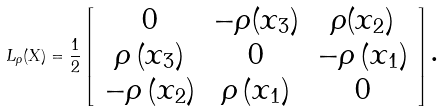Convert formula to latex. <formula><loc_0><loc_0><loc_500><loc_500>L _ { \rho } ( X ) = \frac { 1 } { 2 } \left [ \begin{array} { c c c } 0 & - \rho ( x _ { 3 } ) & \rho ( x _ { 2 } ) \\ \rho \left ( x _ { 3 } \right ) & 0 & - \rho \left ( x _ { 1 } \right ) \\ - \rho \left ( x _ { 2 } \right ) & \rho \left ( x _ { 1 } \right ) & 0 \end{array} \right ] \text {.}</formula> 